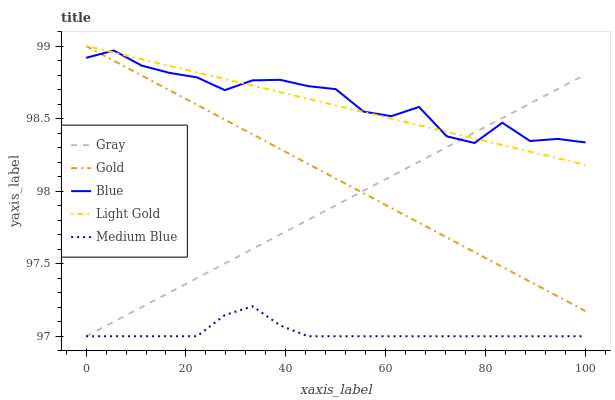Does Gray have the minimum area under the curve?
Answer yes or no. No. Does Gray have the maximum area under the curve?
Answer yes or no. No. Is Gray the smoothest?
Answer yes or no. No. Is Gray the roughest?
Answer yes or no. No. Does Light Gold have the lowest value?
Answer yes or no. No. Does Gray have the highest value?
Answer yes or no. No. Is Medium Blue less than Light Gold?
Answer yes or no. Yes. Is Light Gold greater than Medium Blue?
Answer yes or no. Yes. Does Medium Blue intersect Light Gold?
Answer yes or no. No. 